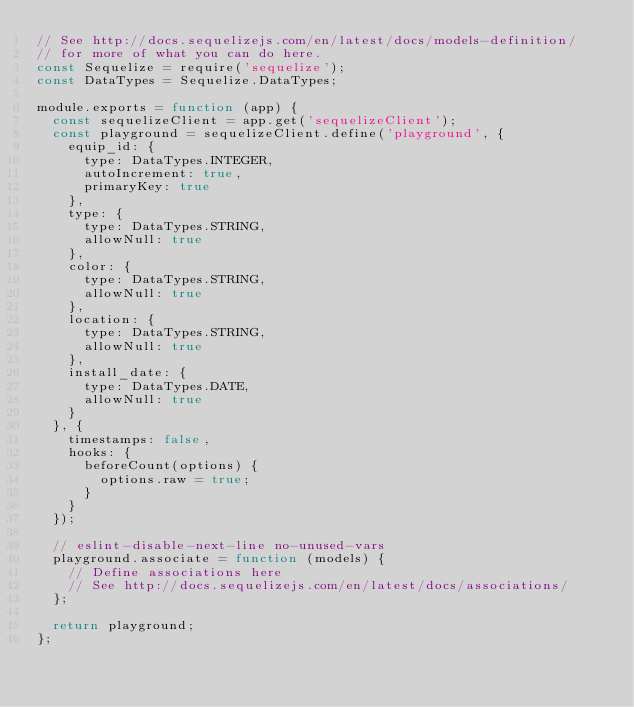<code> <loc_0><loc_0><loc_500><loc_500><_JavaScript_>// See http://docs.sequelizejs.com/en/latest/docs/models-definition/
// for more of what you can do here.
const Sequelize = require('sequelize');
const DataTypes = Sequelize.DataTypes;

module.exports = function (app) {
  const sequelizeClient = app.get('sequelizeClient');
  const playground = sequelizeClient.define('playground', {
    equip_id: {
      type: DataTypes.INTEGER,
      autoIncrement: true,
      primaryKey: true
    },
    type: {
      type: DataTypes.STRING,
      allowNull: true
    },
    color: {
      type: DataTypes.STRING,
      allowNull: true
    },
    location: {
      type: DataTypes.STRING,
      allowNull: true
    },
    install_date: {
      type: DataTypes.DATE,
      allowNull: true
    }
  }, {
    timestamps: false,
    hooks: {
      beforeCount(options) {
        options.raw = true;
      }
    }
  });

  // eslint-disable-next-line no-unused-vars
  playground.associate = function (models) {
    // Define associations here
    // See http://docs.sequelizejs.com/en/latest/docs/associations/
  };

  return playground;
};
</code> 